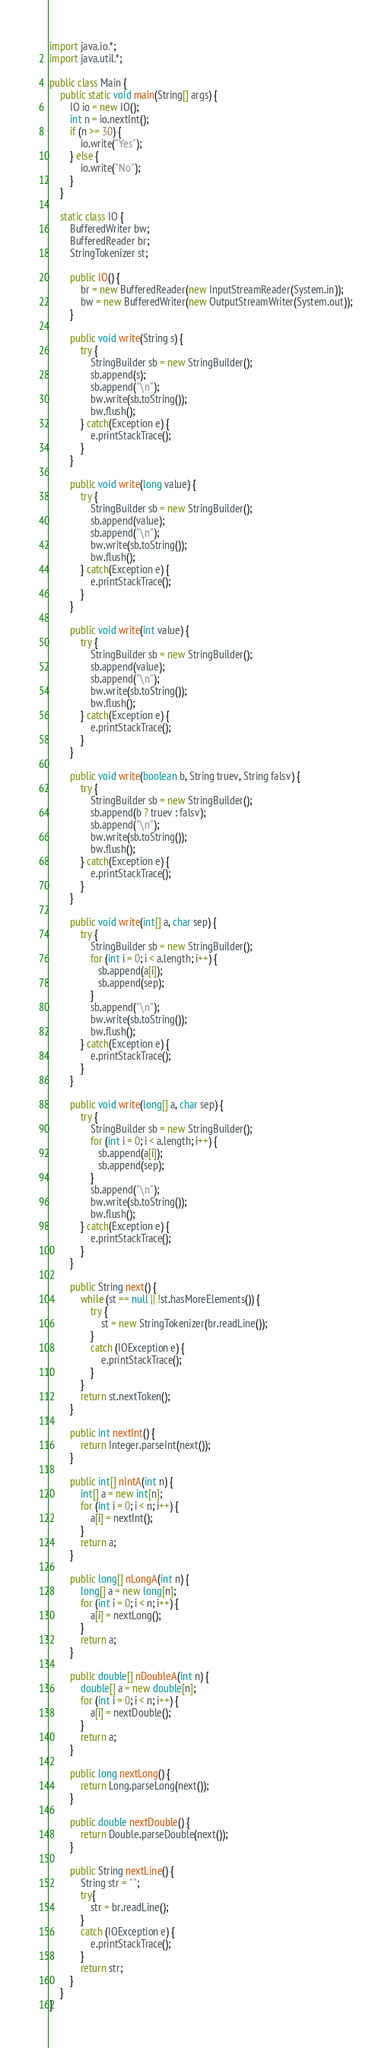Convert code to text. <code><loc_0><loc_0><loc_500><loc_500><_Java_>import java.io.*;
import java.util.*;

public class Main {
    public static void main(String[] args) {
        IO io = new IO();
        int n = io.nextInt();
        if (n >= 30) {
            io.write("Yes");
        } else {
            io.write("No");
        }
    }
    
    static class IO {
        BufferedWriter bw;
        BufferedReader br;
        StringTokenizer st;

        public IO() {
            br = new BufferedReader(new InputStreamReader(System.in));
            bw = new BufferedWriter(new OutputStreamWriter(System.out));
        }

        public void write(String s) {
            try {
                StringBuilder sb = new StringBuilder();
                sb.append(s);
                sb.append("\n");
                bw.write(sb.toString());
                bw.flush();
            } catch(Exception e) {
                e.printStackTrace();
            }  
        }

        public void write(long value) {
            try {
                StringBuilder sb = new StringBuilder();
                sb.append(value);
                sb.append("\n");
                bw.write(sb.toString());
                bw.flush();
            } catch(Exception e) {
                e.printStackTrace();
            }
        }

        public void write(int value) {
            try {
                StringBuilder sb = new StringBuilder();
                sb.append(value);
                sb.append("\n");
                bw.write(sb.toString());
                bw.flush();
            } catch(Exception e) {
                e.printStackTrace();
            }
        }

        public void write(boolean b, String truev, String falsv) {
            try {
                StringBuilder sb = new StringBuilder();
                sb.append(b ? truev : falsv);
                sb.append("\n");
                bw.write(sb.toString());
                bw.flush();
            } catch(Exception e) {
                e.printStackTrace();
            }
        }

        public void write(int[] a, char sep) {
            try {
                StringBuilder sb = new StringBuilder();
                for (int i = 0; i < a.length; i++) {
                   sb.append(a[i]);
                   sb.append(sep);
                }
                sb.append("\n");
                bw.write(sb.toString());
                bw.flush();
            } catch(Exception e) {
                e.printStackTrace();
            }
        }

        public void write(long[] a, char sep) {
            try {
                StringBuilder sb = new StringBuilder();
                for (int i = 0; i < a.length; i++) {
                   sb.append(a[i]);
                   sb.append(sep);
                }
                sb.append("\n");
                bw.write(sb.toString());
                bw.flush();
            } catch(Exception e) {
                e.printStackTrace();
            }
        }
 
        public String next() {
            while (st == null || !st.hasMoreElements()) {
                try {
                    st = new StringTokenizer(br.readLine());
                }
                catch (IOException e) {
                    e.printStackTrace();
                }
            }
            return st.nextToken();
        }
 
        public int nextInt() {
            return Integer.parseInt(next());
        }

        public int[] nIntA(int n) {
            int[] a = new int[n];
            for (int i = 0; i < n; i++) {
                a[i] = nextInt();
            }
            return a;
        }

        public long[] nLongA(int n) {
            long[] a = new long[n];
            for (int i = 0; i < n; i++) {
                a[i] = nextLong();
            }
            return a;
        }

        public double[] nDoubleA(int n) {
            double[] a = new double[n];
            for (int i = 0; i < n; i++) {
                a[i] = nextDouble();
            }
            return a;
        }
 
        public long nextLong() {
            return Long.parseLong(next());
        }
 
        public double nextDouble() {
            return Double.parseDouble(next());
        }
 
        public String nextLine() {
            String str = "";
            try{
                str = br.readLine();
            }
            catch (IOException e) {
                e.printStackTrace();
            }
            return str;
        }
    }
}</code> 